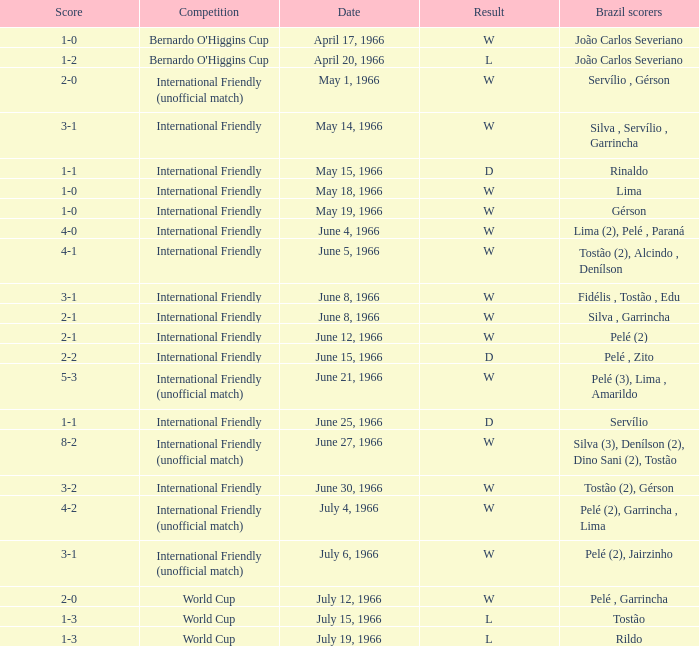What competition has a result of W on June 30, 1966? International Friendly. 